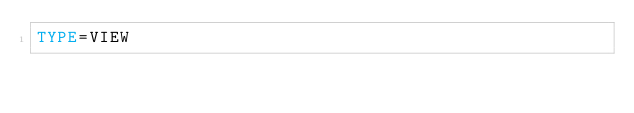<code> <loc_0><loc_0><loc_500><loc_500><_VisualBasic_>TYPE=VIEW</code> 